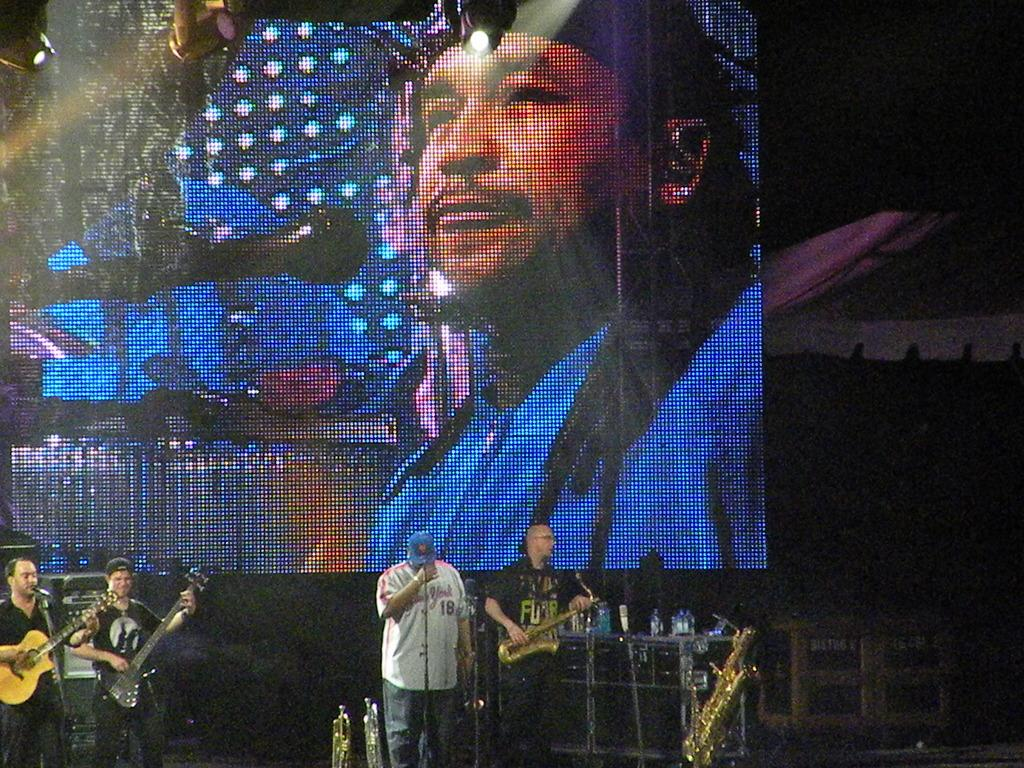What are the guys in the image doing? The guys in the image are playing musical instruments. How are the musical instruments being used? The musical instruments are held in their hands. What is in front of the guys? There is a microphone in front of them. What can be seen behind the guys? There is a digital screen visible behind them. What type of leaf is being used as a prop in the image? There is no leaf present in the image; the guys are playing musical instruments and there is a microphone and digital screen visible. 